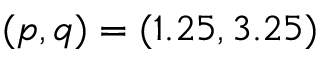<formula> <loc_0><loc_0><loc_500><loc_500>( p , q ) = ( 1 . 2 5 , 3 . 2 5 )</formula> 